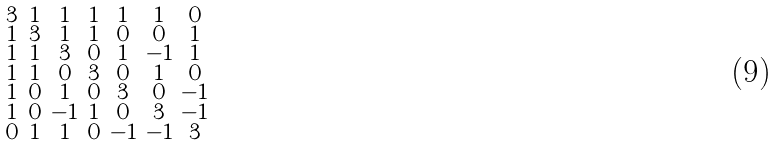<formula> <loc_0><loc_0><loc_500><loc_500>\begin{smallmatrix} 3 & 1 & 1 & 1 & 1 & 1 & 0 \\ 1 & 3 & 1 & 1 & 0 & 0 & 1 \\ 1 & 1 & 3 & 0 & 1 & - 1 & 1 \\ 1 & 1 & 0 & 3 & 0 & 1 & 0 \\ 1 & 0 & 1 & 0 & 3 & 0 & - 1 \\ 1 & 0 & - 1 & 1 & 0 & 3 & - 1 \\ 0 & 1 & 1 & 0 & - 1 & - 1 & 3 \end{smallmatrix}</formula> 